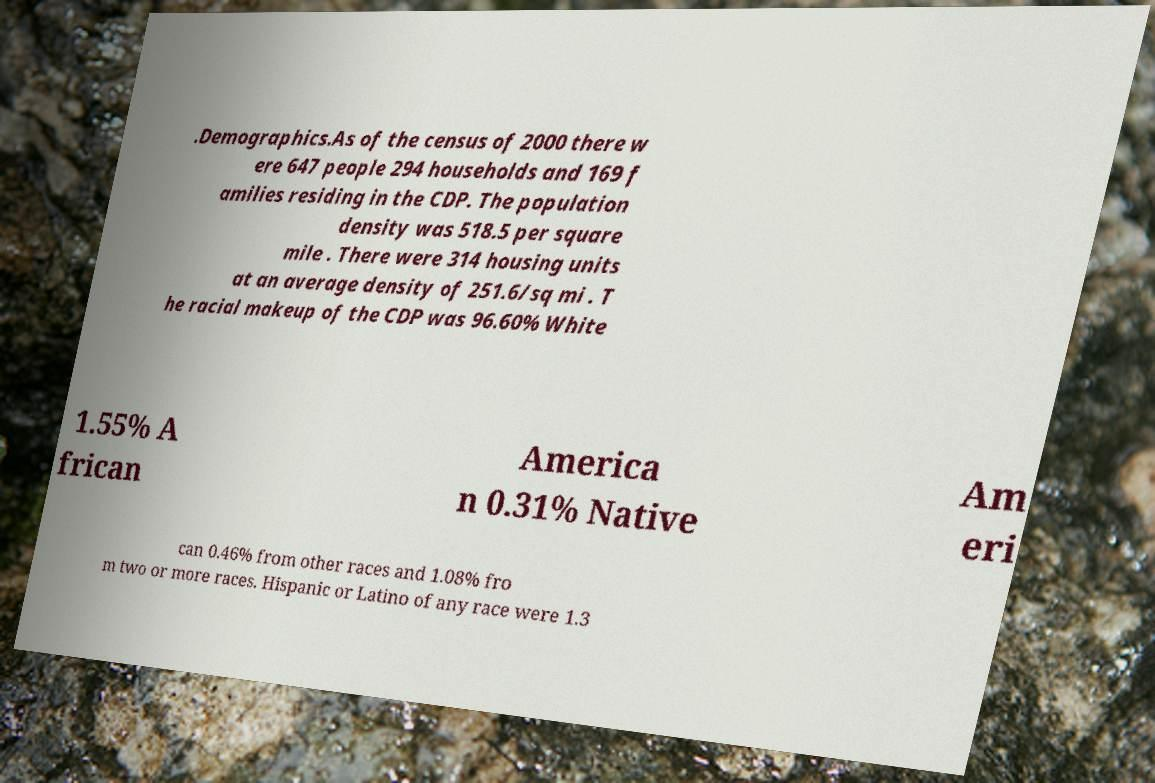I need the written content from this picture converted into text. Can you do that? .Demographics.As of the census of 2000 there w ere 647 people 294 households and 169 f amilies residing in the CDP. The population density was 518.5 per square mile . There were 314 housing units at an average density of 251.6/sq mi . T he racial makeup of the CDP was 96.60% White 1.55% A frican America n 0.31% Native Am eri can 0.46% from other races and 1.08% fro m two or more races. Hispanic or Latino of any race were 1.3 